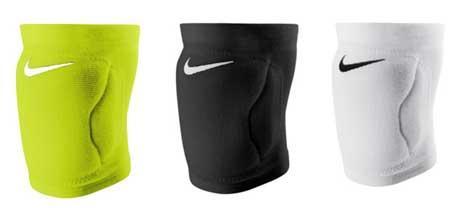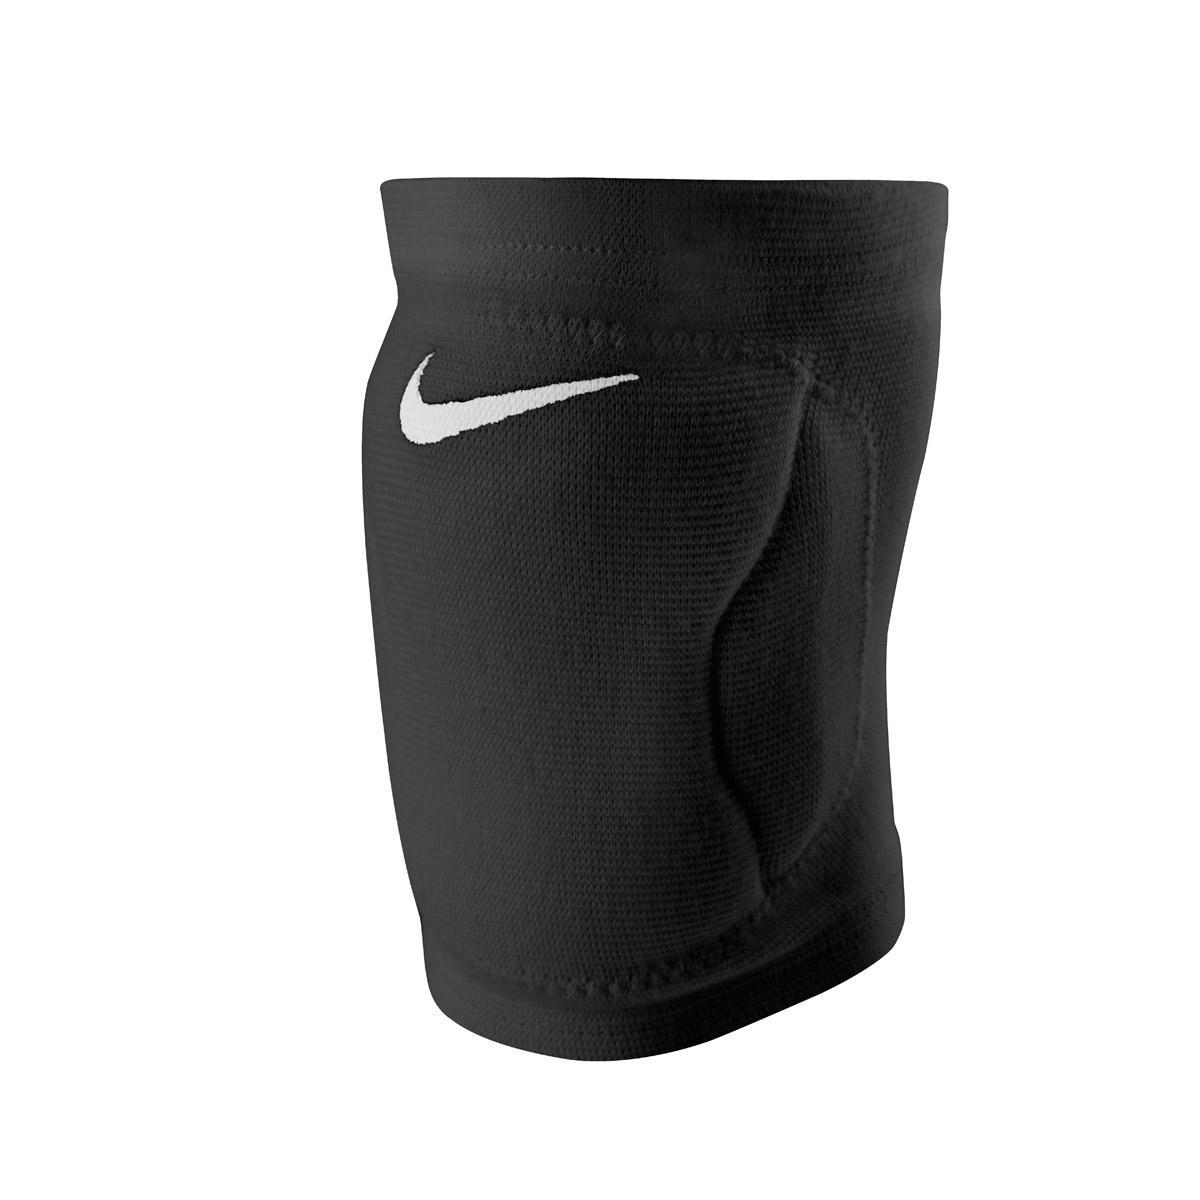The first image is the image on the left, the second image is the image on the right. Given the left and right images, does the statement "Each image shows a pair of knee wraps." hold true? Answer yes or no. No. 